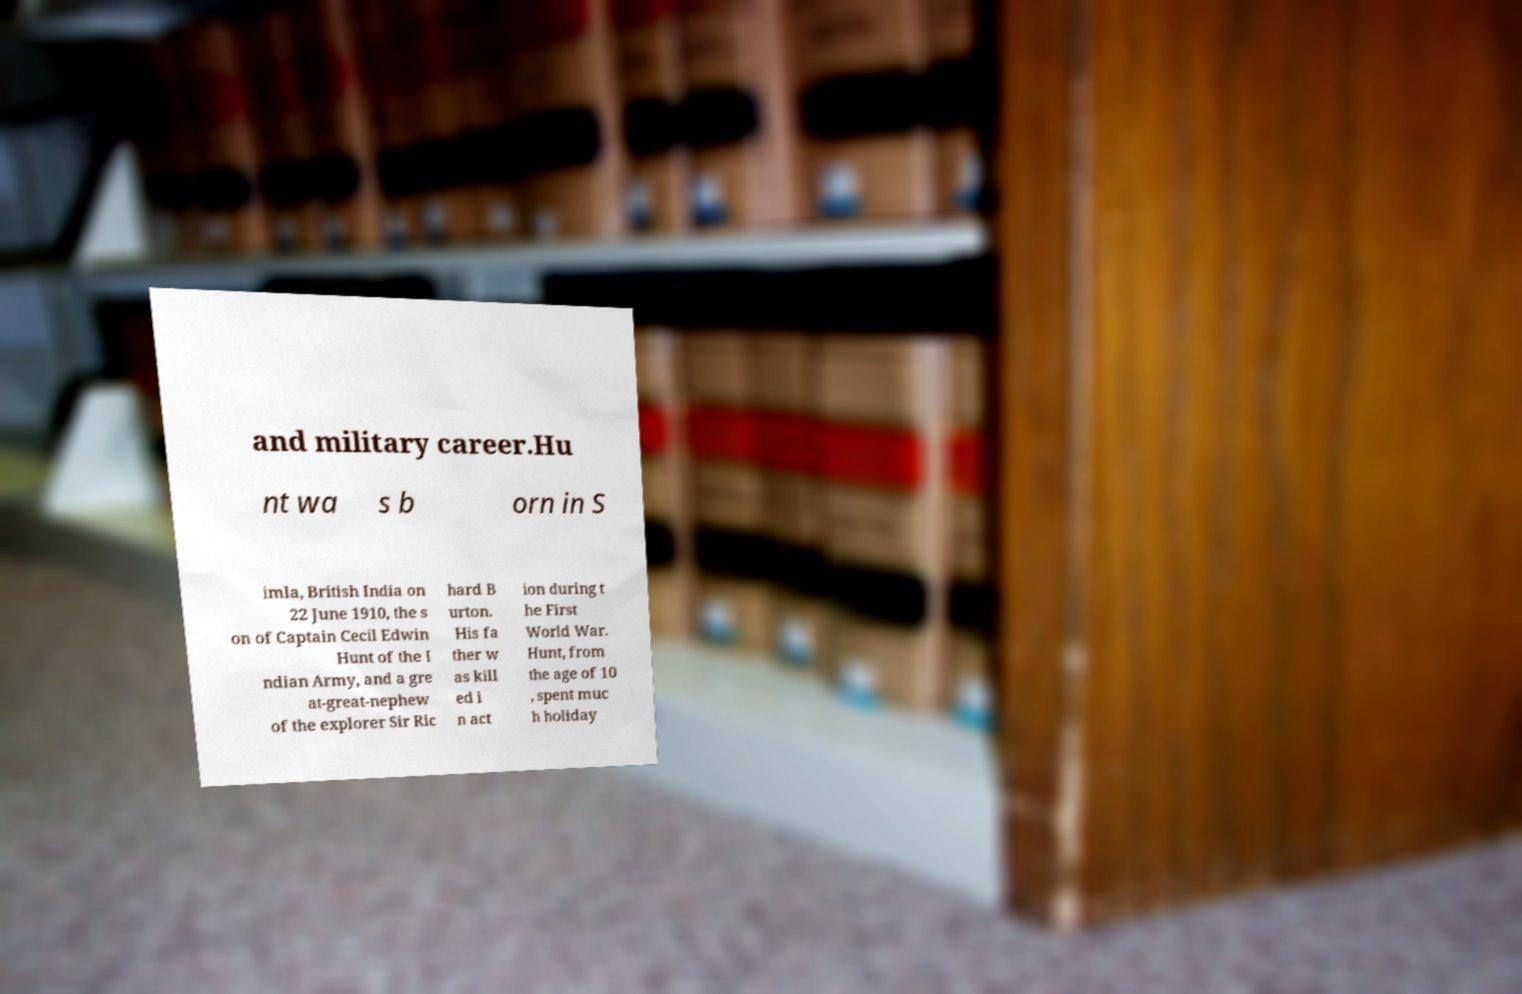For documentation purposes, I need the text within this image transcribed. Could you provide that? and military career.Hu nt wa s b orn in S imla, British India on 22 June 1910, the s on of Captain Cecil Edwin Hunt of the I ndian Army, and a gre at-great-nephew of the explorer Sir Ric hard B urton. His fa ther w as kill ed i n act ion during t he First World War. Hunt, from the age of 10 , spent muc h holiday 